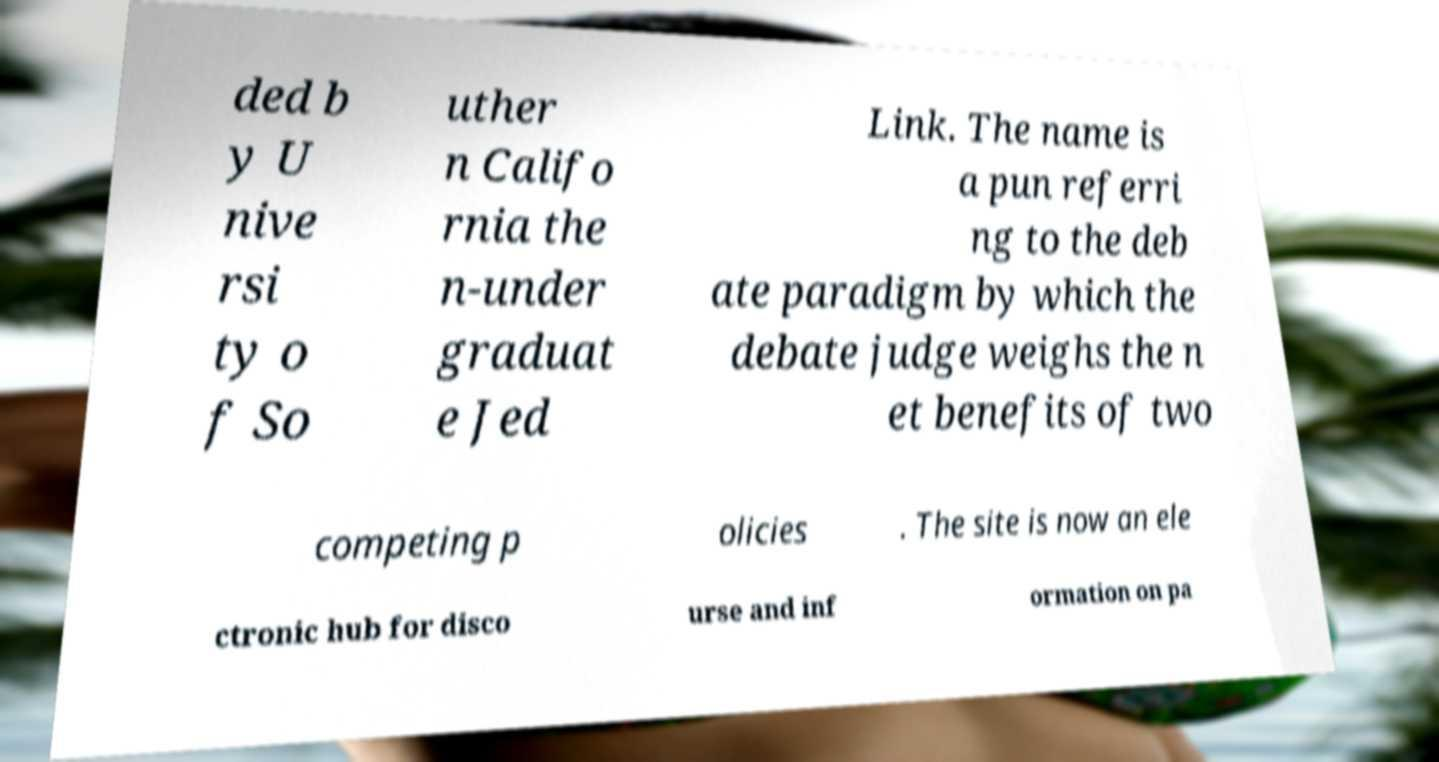What messages or text are displayed in this image? I need them in a readable, typed format. ded b y U nive rsi ty o f So uther n Califo rnia the n-under graduat e Jed Link. The name is a pun referri ng to the deb ate paradigm by which the debate judge weighs the n et benefits of two competing p olicies . The site is now an ele ctronic hub for disco urse and inf ormation on pa 